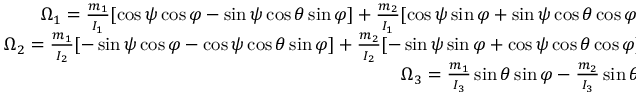Convert formula to latex. <formula><loc_0><loc_0><loc_500><loc_500>\begin{array} { r } { \Omega _ { 1 } = \frac { m _ { 1 } } { I _ { 1 } } [ \cos \psi \cos \varphi - \sin \psi \cos \theta \sin \varphi ] + \frac { m _ { 2 } } { I _ { 1 } } [ \cos \psi \sin \varphi + \sin \psi \cos \theta \cos \varphi ] + \frac { m _ { 3 } } { I _ { 1 } } \sin \psi \sin \theta , } \\ { \Omega _ { 2 } = \frac { m _ { 1 } } { I _ { 2 } } [ - \sin \psi \cos \varphi - \cos \psi \cos \theta \sin \varphi ] + \frac { m _ { 2 } } { I _ { 2 } } [ - \sin \psi \sin \varphi + \cos \psi \cos \theta \cos \varphi ] + \frac { m _ { 3 } } { I _ { 2 } } \cos \psi \sin \theta , } \\ { \Omega _ { 3 } = \frac { m _ { 1 } } { I _ { 3 } } \sin \theta \sin \varphi - \frac { m _ { 2 } } { I _ { 3 } } \sin \theta \cos \varphi + \frac { m _ { 3 } } { I _ { 3 } } \cos \theta . } \end{array}</formula> 